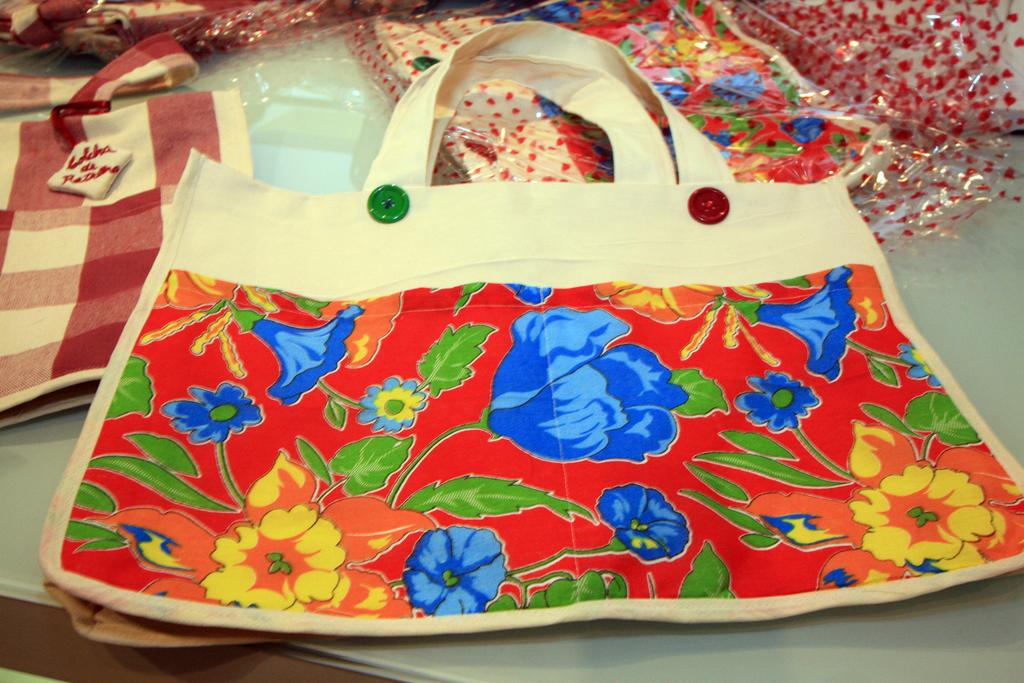What type of bags are visible in the image? There are cloth bags in the image. What feature can be seen on the front bag? The front bag has two buttons. What colors are the buttons on the front bag? The buttons are red and green in color. What design is visible on the front bag? The front bag has a floral print. What can be found at the back of the bags? There are covers at the back of the bags. What type of birthday celebration is depicted in the image? There is no birthday celebration depicted in the image; it features cloth bags with buttons, a floral print, and covers. Is there a fight happening between the bags in the image? No, there is no fight depicted in the image; it shows cloth bags with various features. 